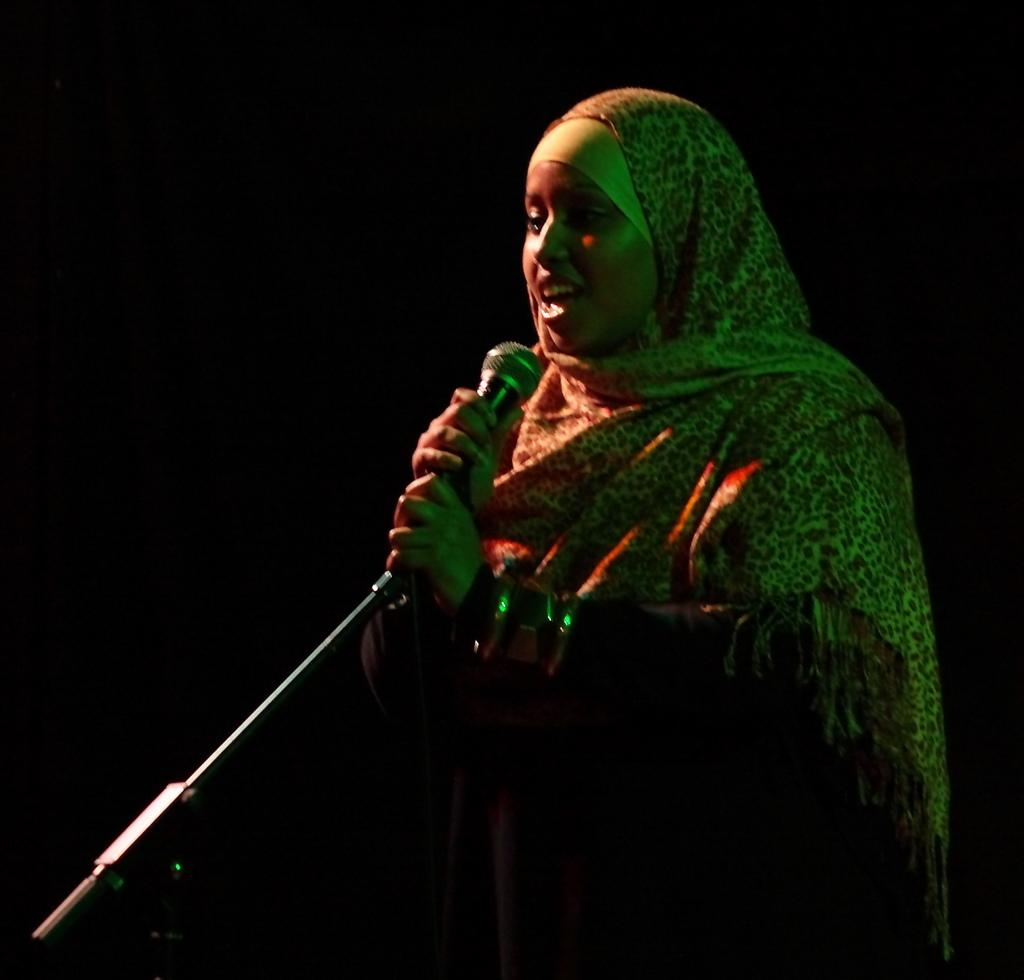What is the main subject of the image? The main subject of the image is a woman. What is the woman doing in the image? The woman is standing and holding a mic in her hand. Is the mic attached to anything in the image? Yes, the mic is on a stand. What is the woman wearing in the image? The woman is wearing a scarf. How would you describe the background of the image? The background of the image is dark. What is the size of the list the woman is holding in the image? There is no list present in the image; the woman is holding a mic. How does the woman's cough affect the sound quality of the mic in the image? There is no cough mentioned in the image; the woman is simply holding a mic. 